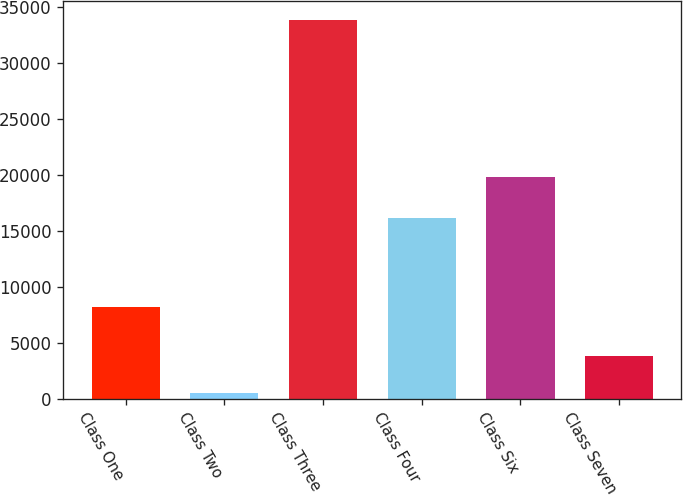<chart> <loc_0><loc_0><loc_500><loc_500><bar_chart><fcel>Class One<fcel>Class Two<fcel>Class Three<fcel>Class Four<fcel>Class Six<fcel>Class Seven<nl><fcel>8229<fcel>465<fcel>33852<fcel>16124<fcel>19772<fcel>3803.7<nl></chart> 